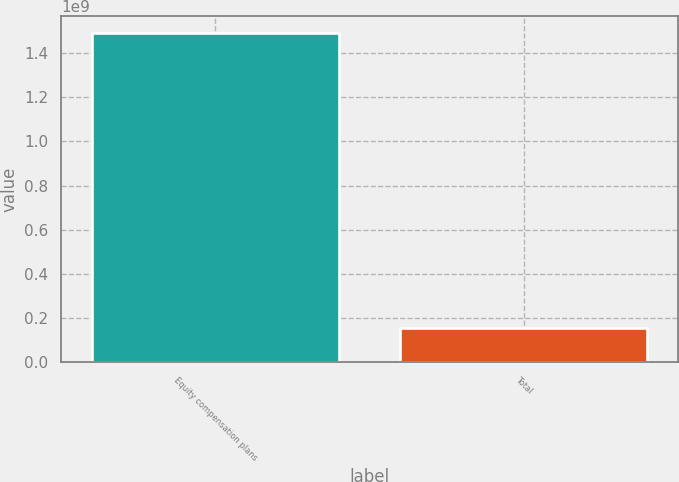Convert chart. <chart><loc_0><loc_0><loc_500><loc_500><bar_chart><fcel>Equity compensation plans<fcel>Total<nl><fcel>1.49206e+09<fcel>1.542e+08<nl></chart> 